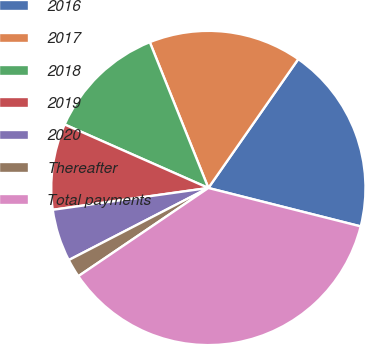Convert chart. <chart><loc_0><loc_0><loc_500><loc_500><pie_chart><fcel>2016<fcel>2017<fcel>2018<fcel>2019<fcel>2020<fcel>Thereafter<fcel>Total payments<nl><fcel>19.24%<fcel>15.77%<fcel>12.3%<fcel>8.84%<fcel>5.37%<fcel>1.9%<fcel>36.58%<nl></chart> 